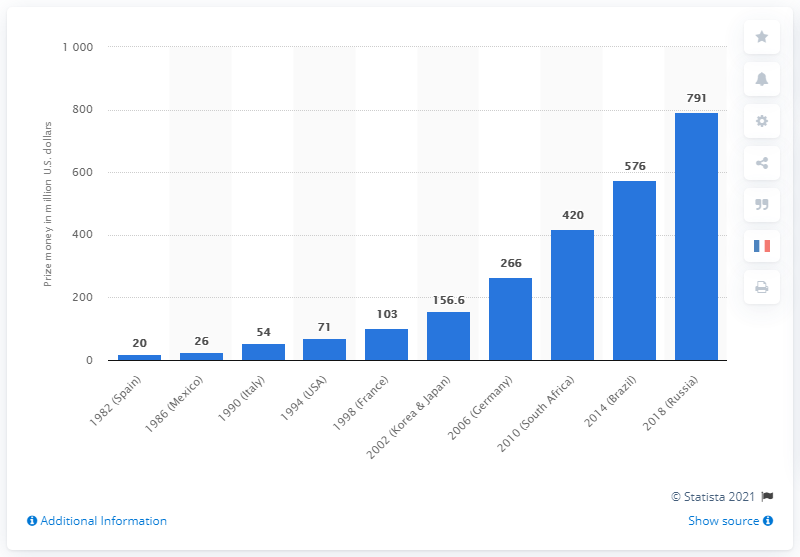List a handful of essential elements in this visual. The total prize money for the 2018 FIFA World Cup held in Russia was 791 million dollars. The amount of money available for the previous World Cup, which was held in Brazil in 2014, was 576 million dollars. In the 1990s, the average prize money in the USA and France was approximately 87 million dollars. In 2018, the price money was the greatest in Russia. 